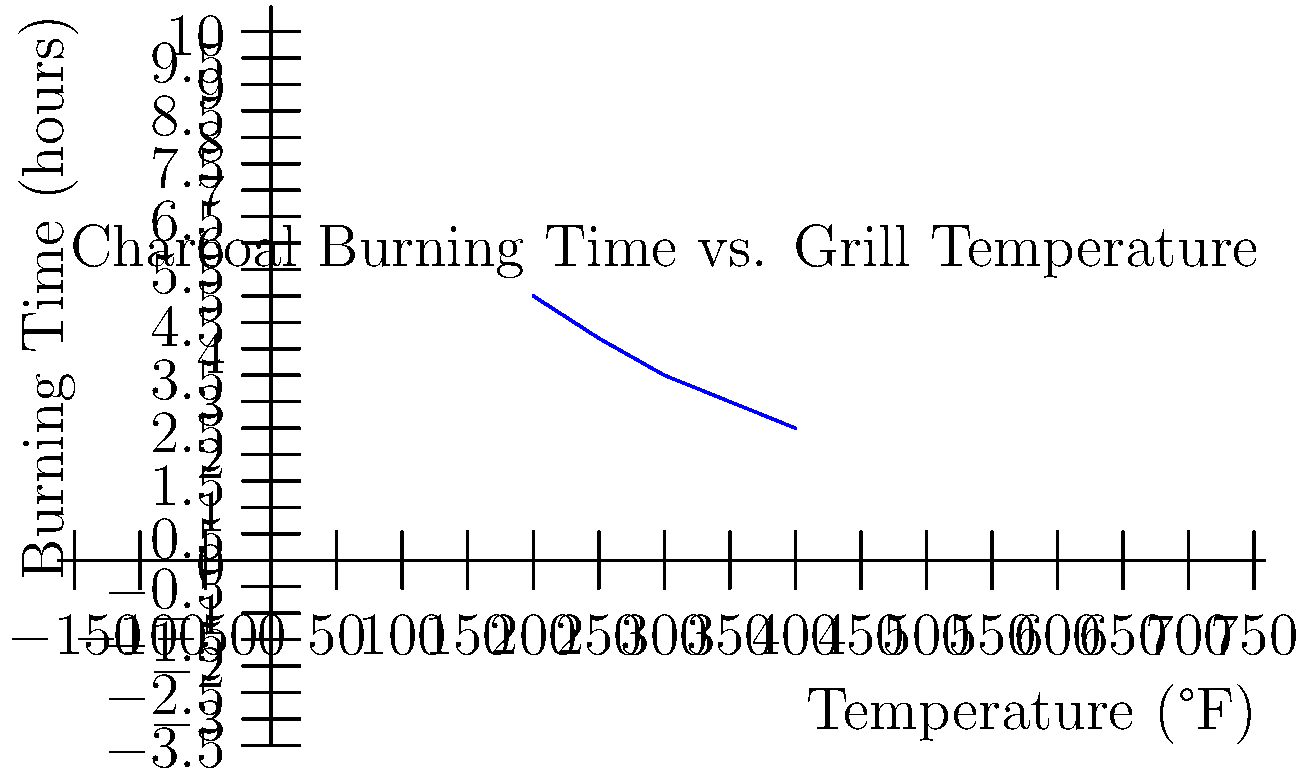As a barbecue enthusiast, you're preparing for a classic rock-themed cookout. Using the line graph showing the relationship between grill temperature and charcoal burning time, estimate how long a batch of charcoal will burn at 275°F. Round your answer to the nearest quarter hour. To solve this problem, we'll follow these steps:

1. Observe that the graph shows an inverse relationship between temperature and burning time.

2. Locate 275°F on the x-axis (temperature). It falls between 250°F and 300°F.

3. Find the corresponding y-values (burning time) for 250°F and 300°F:
   - At 250°F: approximately 4.2 hours
   - At 300°F: approximately 3.5 hours

4. Since 275°F is halfway between 250°F and 300°F, we can estimate the burning time by taking the average of the two corresponding y-values:

   $\frac{4.2 + 3.5}{2} = \frac{7.7}{2} = 3.85$ hours

5. Rounding to the nearest quarter hour:
   3.85 hours is closest to 3.75 hours, which is 3 hours and 45 minutes.

Therefore, at 275°F, we can estimate that the charcoal will burn for approximately 3.75 hours or 3 hours and 45 minutes.
Answer: 3.75 hours 